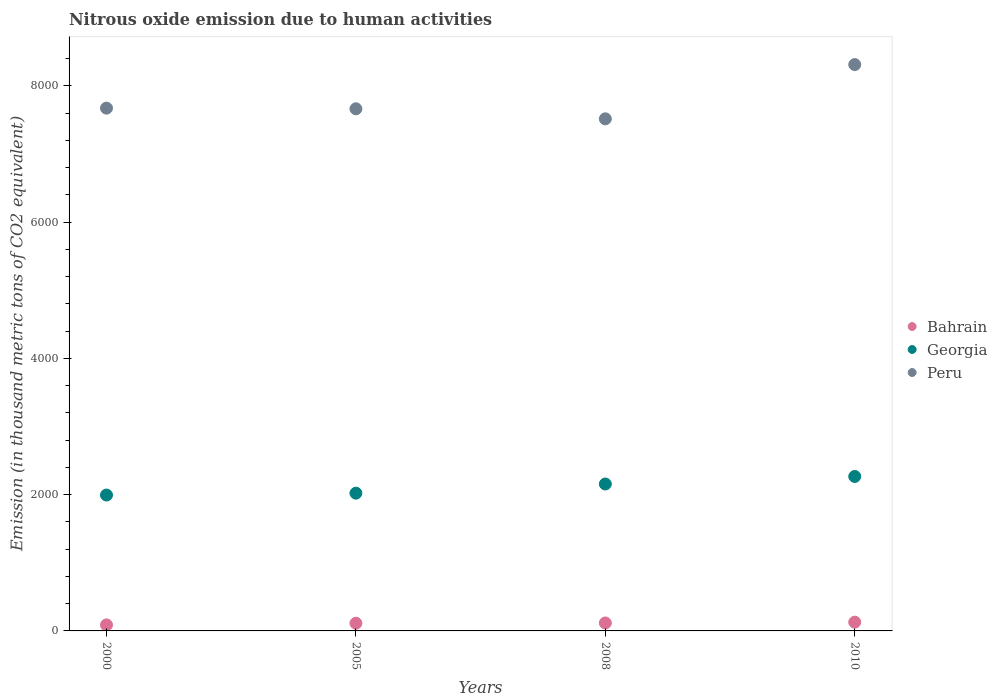Is the number of dotlines equal to the number of legend labels?
Ensure brevity in your answer.  Yes. What is the amount of nitrous oxide emitted in Peru in 2008?
Your answer should be compact. 7516.8. Across all years, what is the maximum amount of nitrous oxide emitted in Bahrain?
Your answer should be very brief. 128.6. Across all years, what is the minimum amount of nitrous oxide emitted in Peru?
Offer a very short reply. 7516.8. In which year was the amount of nitrous oxide emitted in Peru maximum?
Ensure brevity in your answer.  2010. In which year was the amount of nitrous oxide emitted in Georgia minimum?
Ensure brevity in your answer.  2000. What is the total amount of nitrous oxide emitted in Georgia in the graph?
Ensure brevity in your answer.  8440.4. What is the difference between the amount of nitrous oxide emitted in Peru in 2005 and that in 2010?
Provide a short and direct response. -648.8. What is the difference between the amount of nitrous oxide emitted in Peru in 2000 and the amount of nitrous oxide emitted in Georgia in 2008?
Provide a succinct answer. 5517.3. What is the average amount of nitrous oxide emitted in Bahrain per year?
Offer a terse response. 111.6. In the year 2005, what is the difference between the amount of nitrous oxide emitted in Peru and amount of nitrous oxide emitted in Georgia?
Your answer should be very brief. 5642.2. What is the ratio of the amount of nitrous oxide emitted in Bahrain in 2005 to that in 2010?
Make the answer very short. 0.88. Is the difference between the amount of nitrous oxide emitted in Peru in 2005 and 2008 greater than the difference between the amount of nitrous oxide emitted in Georgia in 2005 and 2008?
Ensure brevity in your answer.  Yes. What is the difference between the highest and the second highest amount of nitrous oxide emitted in Georgia?
Your answer should be very brief. 110.7. What is the difference between the highest and the lowest amount of nitrous oxide emitted in Georgia?
Your response must be concise. 272.8. In how many years, is the amount of nitrous oxide emitted in Bahrain greater than the average amount of nitrous oxide emitted in Bahrain taken over all years?
Make the answer very short. 3. Is it the case that in every year, the sum of the amount of nitrous oxide emitted in Georgia and amount of nitrous oxide emitted in Peru  is greater than the amount of nitrous oxide emitted in Bahrain?
Your answer should be compact. Yes. Is the amount of nitrous oxide emitted in Peru strictly less than the amount of nitrous oxide emitted in Bahrain over the years?
Ensure brevity in your answer.  No. How many years are there in the graph?
Your response must be concise. 4. What is the difference between two consecutive major ticks on the Y-axis?
Offer a very short reply. 2000. Does the graph contain grids?
Your answer should be very brief. No. Where does the legend appear in the graph?
Ensure brevity in your answer.  Center right. How many legend labels are there?
Provide a short and direct response. 3. How are the legend labels stacked?
Your answer should be very brief. Vertical. What is the title of the graph?
Provide a short and direct response. Nitrous oxide emission due to human activities. Does "Philippines" appear as one of the legend labels in the graph?
Offer a very short reply. No. What is the label or title of the X-axis?
Offer a terse response. Years. What is the label or title of the Y-axis?
Your answer should be compact. Emission (in thousand metric tons of CO2 equivalent). What is the Emission (in thousand metric tons of CO2 equivalent) in Bahrain in 2000?
Keep it short and to the point. 88.2. What is the Emission (in thousand metric tons of CO2 equivalent) in Georgia in 2000?
Provide a succinct answer. 1994.5. What is the Emission (in thousand metric tons of CO2 equivalent) in Peru in 2000?
Your answer should be compact. 7673.9. What is the Emission (in thousand metric tons of CO2 equivalent) of Bahrain in 2005?
Your answer should be very brief. 112.9. What is the Emission (in thousand metric tons of CO2 equivalent) in Georgia in 2005?
Provide a short and direct response. 2022. What is the Emission (in thousand metric tons of CO2 equivalent) in Peru in 2005?
Offer a terse response. 7664.2. What is the Emission (in thousand metric tons of CO2 equivalent) of Bahrain in 2008?
Give a very brief answer. 116.7. What is the Emission (in thousand metric tons of CO2 equivalent) of Georgia in 2008?
Give a very brief answer. 2156.6. What is the Emission (in thousand metric tons of CO2 equivalent) in Peru in 2008?
Make the answer very short. 7516.8. What is the Emission (in thousand metric tons of CO2 equivalent) in Bahrain in 2010?
Provide a short and direct response. 128.6. What is the Emission (in thousand metric tons of CO2 equivalent) in Georgia in 2010?
Give a very brief answer. 2267.3. What is the Emission (in thousand metric tons of CO2 equivalent) in Peru in 2010?
Keep it short and to the point. 8313. Across all years, what is the maximum Emission (in thousand metric tons of CO2 equivalent) of Bahrain?
Your response must be concise. 128.6. Across all years, what is the maximum Emission (in thousand metric tons of CO2 equivalent) of Georgia?
Your answer should be very brief. 2267.3. Across all years, what is the maximum Emission (in thousand metric tons of CO2 equivalent) of Peru?
Make the answer very short. 8313. Across all years, what is the minimum Emission (in thousand metric tons of CO2 equivalent) of Bahrain?
Offer a terse response. 88.2. Across all years, what is the minimum Emission (in thousand metric tons of CO2 equivalent) in Georgia?
Make the answer very short. 1994.5. Across all years, what is the minimum Emission (in thousand metric tons of CO2 equivalent) of Peru?
Your answer should be compact. 7516.8. What is the total Emission (in thousand metric tons of CO2 equivalent) of Bahrain in the graph?
Your response must be concise. 446.4. What is the total Emission (in thousand metric tons of CO2 equivalent) in Georgia in the graph?
Provide a short and direct response. 8440.4. What is the total Emission (in thousand metric tons of CO2 equivalent) of Peru in the graph?
Offer a very short reply. 3.12e+04. What is the difference between the Emission (in thousand metric tons of CO2 equivalent) of Bahrain in 2000 and that in 2005?
Keep it short and to the point. -24.7. What is the difference between the Emission (in thousand metric tons of CO2 equivalent) in Georgia in 2000 and that in 2005?
Keep it short and to the point. -27.5. What is the difference between the Emission (in thousand metric tons of CO2 equivalent) of Bahrain in 2000 and that in 2008?
Make the answer very short. -28.5. What is the difference between the Emission (in thousand metric tons of CO2 equivalent) of Georgia in 2000 and that in 2008?
Give a very brief answer. -162.1. What is the difference between the Emission (in thousand metric tons of CO2 equivalent) of Peru in 2000 and that in 2008?
Make the answer very short. 157.1. What is the difference between the Emission (in thousand metric tons of CO2 equivalent) in Bahrain in 2000 and that in 2010?
Provide a short and direct response. -40.4. What is the difference between the Emission (in thousand metric tons of CO2 equivalent) in Georgia in 2000 and that in 2010?
Offer a terse response. -272.8. What is the difference between the Emission (in thousand metric tons of CO2 equivalent) of Peru in 2000 and that in 2010?
Offer a very short reply. -639.1. What is the difference between the Emission (in thousand metric tons of CO2 equivalent) of Georgia in 2005 and that in 2008?
Offer a very short reply. -134.6. What is the difference between the Emission (in thousand metric tons of CO2 equivalent) in Peru in 2005 and that in 2008?
Make the answer very short. 147.4. What is the difference between the Emission (in thousand metric tons of CO2 equivalent) of Bahrain in 2005 and that in 2010?
Offer a very short reply. -15.7. What is the difference between the Emission (in thousand metric tons of CO2 equivalent) of Georgia in 2005 and that in 2010?
Keep it short and to the point. -245.3. What is the difference between the Emission (in thousand metric tons of CO2 equivalent) in Peru in 2005 and that in 2010?
Offer a terse response. -648.8. What is the difference between the Emission (in thousand metric tons of CO2 equivalent) in Bahrain in 2008 and that in 2010?
Your response must be concise. -11.9. What is the difference between the Emission (in thousand metric tons of CO2 equivalent) in Georgia in 2008 and that in 2010?
Keep it short and to the point. -110.7. What is the difference between the Emission (in thousand metric tons of CO2 equivalent) in Peru in 2008 and that in 2010?
Provide a short and direct response. -796.2. What is the difference between the Emission (in thousand metric tons of CO2 equivalent) of Bahrain in 2000 and the Emission (in thousand metric tons of CO2 equivalent) of Georgia in 2005?
Make the answer very short. -1933.8. What is the difference between the Emission (in thousand metric tons of CO2 equivalent) in Bahrain in 2000 and the Emission (in thousand metric tons of CO2 equivalent) in Peru in 2005?
Your response must be concise. -7576. What is the difference between the Emission (in thousand metric tons of CO2 equivalent) in Georgia in 2000 and the Emission (in thousand metric tons of CO2 equivalent) in Peru in 2005?
Give a very brief answer. -5669.7. What is the difference between the Emission (in thousand metric tons of CO2 equivalent) in Bahrain in 2000 and the Emission (in thousand metric tons of CO2 equivalent) in Georgia in 2008?
Provide a short and direct response. -2068.4. What is the difference between the Emission (in thousand metric tons of CO2 equivalent) in Bahrain in 2000 and the Emission (in thousand metric tons of CO2 equivalent) in Peru in 2008?
Keep it short and to the point. -7428.6. What is the difference between the Emission (in thousand metric tons of CO2 equivalent) of Georgia in 2000 and the Emission (in thousand metric tons of CO2 equivalent) of Peru in 2008?
Offer a very short reply. -5522.3. What is the difference between the Emission (in thousand metric tons of CO2 equivalent) in Bahrain in 2000 and the Emission (in thousand metric tons of CO2 equivalent) in Georgia in 2010?
Offer a terse response. -2179.1. What is the difference between the Emission (in thousand metric tons of CO2 equivalent) of Bahrain in 2000 and the Emission (in thousand metric tons of CO2 equivalent) of Peru in 2010?
Your response must be concise. -8224.8. What is the difference between the Emission (in thousand metric tons of CO2 equivalent) in Georgia in 2000 and the Emission (in thousand metric tons of CO2 equivalent) in Peru in 2010?
Offer a very short reply. -6318.5. What is the difference between the Emission (in thousand metric tons of CO2 equivalent) in Bahrain in 2005 and the Emission (in thousand metric tons of CO2 equivalent) in Georgia in 2008?
Offer a terse response. -2043.7. What is the difference between the Emission (in thousand metric tons of CO2 equivalent) in Bahrain in 2005 and the Emission (in thousand metric tons of CO2 equivalent) in Peru in 2008?
Your answer should be very brief. -7403.9. What is the difference between the Emission (in thousand metric tons of CO2 equivalent) in Georgia in 2005 and the Emission (in thousand metric tons of CO2 equivalent) in Peru in 2008?
Keep it short and to the point. -5494.8. What is the difference between the Emission (in thousand metric tons of CO2 equivalent) in Bahrain in 2005 and the Emission (in thousand metric tons of CO2 equivalent) in Georgia in 2010?
Give a very brief answer. -2154.4. What is the difference between the Emission (in thousand metric tons of CO2 equivalent) of Bahrain in 2005 and the Emission (in thousand metric tons of CO2 equivalent) of Peru in 2010?
Provide a succinct answer. -8200.1. What is the difference between the Emission (in thousand metric tons of CO2 equivalent) of Georgia in 2005 and the Emission (in thousand metric tons of CO2 equivalent) of Peru in 2010?
Make the answer very short. -6291. What is the difference between the Emission (in thousand metric tons of CO2 equivalent) of Bahrain in 2008 and the Emission (in thousand metric tons of CO2 equivalent) of Georgia in 2010?
Your answer should be compact. -2150.6. What is the difference between the Emission (in thousand metric tons of CO2 equivalent) in Bahrain in 2008 and the Emission (in thousand metric tons of CO2 equivalent) in Peru in 2010?
Your answer should be compact. -8196.3. What is the difference between the Emission (in thousand metric tons of CO2 equivalent) in Georgia in 2008 and the Emission (in thousand metric tons of CO2 equivalent) in Peru in 2010?
Your answer should be very brief. -6156.4. What is the average Emission (in thousand metric tons of CO2 equivalent) in Bahrain per year?
Your response must be concise. 111.6. What is the average Emission (in thousand metric tons of CO2 equivalent) in Georgia per year?
Ensure brevity in your answer.  2110.1. What is the average Emission (in thousand metric tons of CO2 equivalent) in Peru per year?
Your response must be concise. 7791.98. In the year 2000, what is the difference between the Emission (in thousand metric tons of CO2 equivalent) of Bahrain and Emission (in thousand metric tons of CO2 equivalent) of Georgia?
Keep it short and to the point. -1906.3. In the year 2000, what is the difference between the Emission (in thousand metric tons of CO2 equivalent) in Bahrain and Emission (in thousand metric tons of CO2 equivalent) in Peru?
Provide a short and direct response. -7585.7. In the year 2000, what is the difference between the Emission (in thousand metric tons of CO2 equivalent) of Georgia and Emission (in thousand metric tons of CO2 equivalent) of Peru?
Ensure brevity in your answer.  -5679.4. In the year 2005, what is the difference between the Emission (in thousand metric tons of CO2 equivalent) in Bahrain and Emission (in thousand metric tons of CO2 equivalent) in Georgia?
Give a very brief answer. -1909.1. In the year 2005, what is the difference between the Emission (in thousand metric tons of CO2 equivalent) of Bahrain and Emission (in thousand metric tons of CO2 equivalent) of Peru?
Your answer should be compact. -7551.3. In the year 2005, what is the difference between the Emission (in thousand metric tons of CO2 equivalent) of Georgia and Emission (in thousand metric tons of CO2 equivalent) of Peru?
Offer a terse response. -5642.2. In the year 2008, what is the difference between the Emission (in thousand metric tons of CO2 equivalent) in Bahrain and Emission (in thousand metric tons of CO2 equivalent) in Georgia?
Offer a terse response. -2039.9. In the year 2008, what is the difference between the Emission (in thousand metric tons of CO2 equivalent) of Bahrain and Emission (in thousand metric tons of CO2 equivalent) of Peru?
Keep it short and to the point. -7400.1. In the year 2008, what is the difference between the Emission (in thousand metric tons of CO2 equivalent) in Georgia and Emission (in thousand metric tons of CO2 equivalent) in Peru?
Make the answer very short. -5360.2. In the year 2010, what is the difference between the Emission (in thousand metric tons of CO2 equivalent) in Bahrain and Emission (in thousand metric tons of CO2 equivalent) in Georgia?
Your answer should be very brief. -2138.7. In the year 2010, what is the difference between the Emission (in thousand metric tons of CO2 equivalent) in Bahrain and Emission (in thousand metric tons of CO2 equivalent) in Peru?
Provide a succinct answer. -8184.4. In the year 2010, what is the difference between the Emission (in thousand metric tons of CO2 equivalent) in Georgia and Emission (in thousand metric tons of CO2 equivalent) in Peru?
Ensure brevity in your answer.  -6045.7. What is the ratio of the Emission (in thousand metric tons of CO2 equivalent) of Bahrain in 2000 to that in 2005?
Ensure brevity in your answer.  0.78. What is the ratio of the Emission (in thousand metric tons of CO2 equivalent) of Georgia in 2000 to that in 2005?
Your response must be concise. 0.99. What is the ratio of the Emission (in thousand metric tons of CO2 equivalent) in Bahrain in 2000 to that in 2008?
Offer a terse response. 0.76. What is the ratio of the Emission (in thousand metric tons of CO2 equivalent) in Georgia in 2000 to that in 2008?
Your answer should be compact. 0.92. What is the ratio of the Emission (in thousand metric tons of CO2 equivalent) of Peru in 2000 to that in 2008?
Make the answer very short. 1.02. What is the ratio of the Emission (in thousand metric tons of CO2 equivalent) in Bahrain in 2000 to that in 2010?
Offer a terse response. 0.69. What is the ratio of the Emission (in thousand metric tons of CO2 equivalent) in Georgia in 2000 to that in 2010?
Provide a short and direct response. 0.88. What is the ratio of the Emission (in thousand metric tons of CO2 equivalent) of Bahrain in 2005 to that in 2008?
Make the answer very short. 0.97. What is the ratio of the Emission (in thousand metric tons of CO2 equivalent) in Georgia in 2005 to that in 2008?
Keep it short and to the point. 0.94. What is the ratio of the Emission (in thousand metric tons of CO2 equivalent) of Peru in 2005 to that in 2008?
Your response must be concise. 1.02. What is the ratio of the Emission (in thousand metric tons of CO2 equivalent) in Bahrain in 2005 to that in 2010?
Make the answer very short. 0.88. What is the ratio of the Emission (in thousand metric tons of CO2 equivalent) of Georgia in 2005 to that in 2010?
Give a very brief answer. 0.89. What is the ratio of the Emission (in thousand metric tons of CO2 equivalent) of Peru in 2005 to that in 2010?
Offer a very short reply. 0.92. What is the ratio of the Emission (in thousand metric tons of CO2 equivalent) in Bahrain in 2008 to that in 2010?
Your answer should be compact. 0.91. What is the ratio of the Emission (in thousand metric tons of CO2 equivalent) in Georgia in 2008 to that in 2010?
Provide a short and direct response. 0.95. What is the ratio of the Emission (in thousand metric tons of CO2 equivalent) of Peru in 2008 to that in 2010?
Ensure brevity in your answer.  0.9. What is the difference between the highest and the second highest Emission (in thousand metric tons of CO2 equivalent) in Georgia?
Keep it short and to the point. 110.7. What is the difference between the highest and the second highest Emission (in thousand metric tons of CO2 equivalent) of Peru?
Provide a succinct answer. 639.1. What is the difference between the highest and the lowest Emission (in thousand metric tons of CO2 equivalent) in Bahrain?
Keep it short and to the point. 40.4. What is the difference between the highest and the lowest Emission (in thousand metric tons of CO2 equivalent) of Georgia?
Your answer should be compact. 272.8. What is the difference between the highest and the lowest Emission (in thousand metric tons of CO2 equivalent) of Peru?
Give a very brief answer. 796.2. 